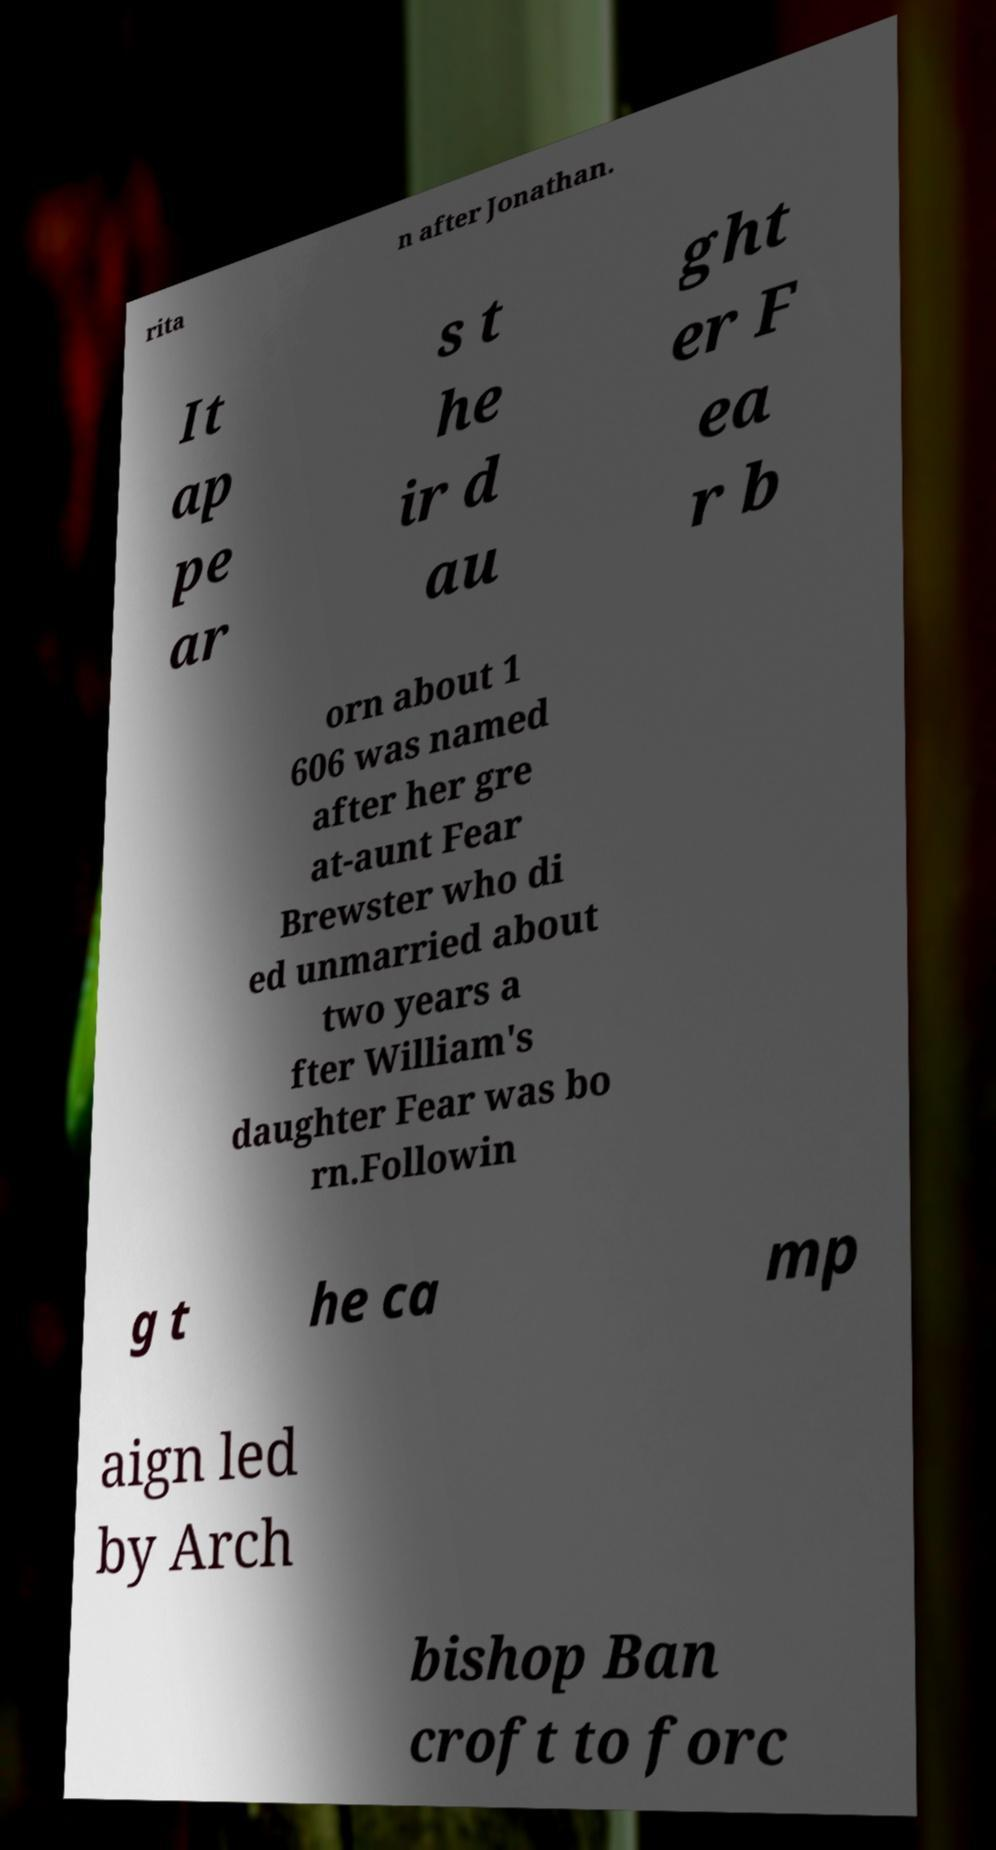Can you accurately transcribe the text from the provided image for me? rita n after Jonathan. It ap pe ar s t he ir d au ght er F ea r b orn about 1 606 was named after her gre at-aunt Fear Brewster who di ed unmarried about two years a fter William's daughter Fear was bo rn.Followin g t he ca mp aign led by Arch bishop Ban croft to forc 